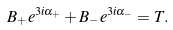Convert formula to latex. <formula><loc_0><loc_0><loc_500><loc_500>B _ { + } e ^ { 3 i \alpha _ { + } } + B _ { - } e ^ { 3 i \alpha _ { - } } = T .</formula> 